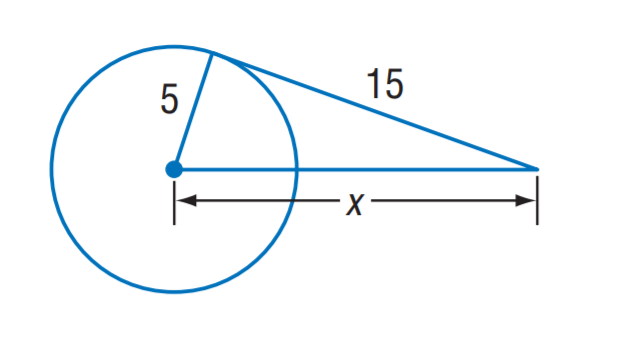Answer the mathemtical geometry problem and directly provide the correct option letter.
Question: The segment is tangent to the circle. Find x.
Choices: A: 5 \sqrt { 5 } B: 5 \sqrt { 10 } C: 10 \sqrt { 5 } D: 10 \sqrt { 10 } B 